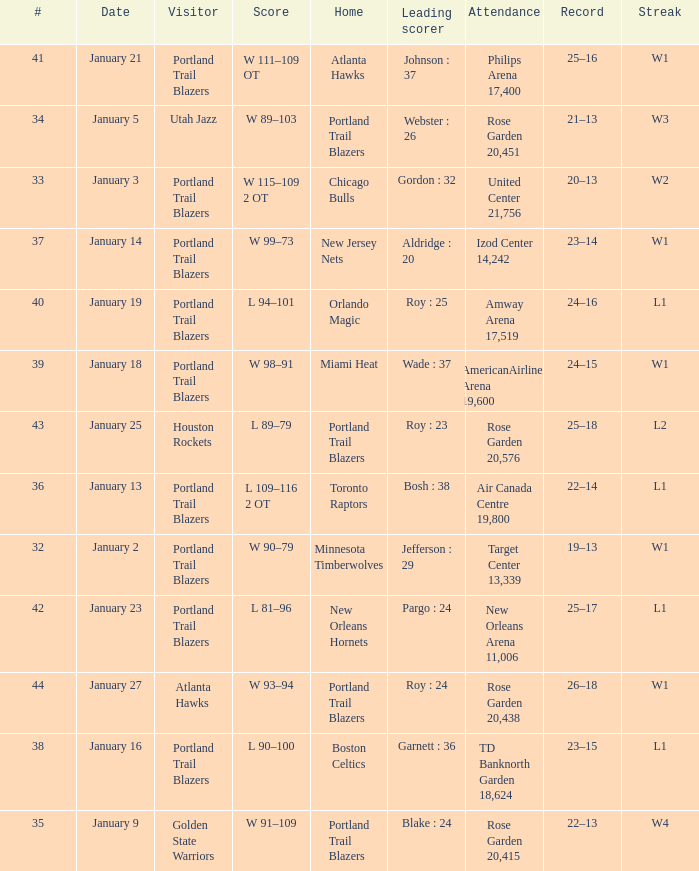Who are all the visitor with a record of 25–18 Houston Rockets. Could you parse the entire table as a dict? {'header': ['#', 'Date', 'Visitor', 'Score', 'Home', 'Leading scorer', 'Attendance', 'Record', 'Streak'], 'rows': [['41', 'January 21', 'Portland Trail Blazers', 'W 111–109 OT', 'Atlanta Hawks', 'Johnson : 37', 'Philips Arena 17,400', '25–16', 'W1'], ['34', 'January 5', 'Utah Jazz', 'W 89–103', 'Portland Trail Blazers', 'Webster : 26', 'Rose Garden 20,451', '21–13', 'W3'], ['33', 'January 3', 'Portland Trail Blazers', 'W 115–109 2 OT', 'Chicago Bulls', 'Gordon : 32', 'United Center 21,756', '20–13', 'W2'], ['37', 'January 14', 'Portland Trail Blazers', 'W 99–73', 'New Jersey Nets', 'Aldridge : 20', 'Izod Center 14,242', '23–14', 'W1'], ['40', 'January 19', 'Portland Trail Blazers', 'L 94–101', 'Orlando Magic', 'Roy : 25', 'Amway Arena 17,519', '24–16', 'L1'], ['39', 'January 18', 'Portland Trail Blazers', 'W 98–91', 'Miami Heat', 'Wade : 37', 'AmericanAirlines Arena 19,600', '24–15', 'W1'], ['43', 'January 25', 'Houston Rockets', 'L 89–79', 'Portland Trail Blazers', 'Roy : 23', 'Rose Garden 20,576', '25–18', 'L2'], ['36', 'January 13', 'Portland Trail Blazers', 'L 109–116 2 OT', 'Toronto Raptors', 'Bosh : 38', 'Air Canada Centre 19,800', '22–14', 'L1'], ['32', 'January 2', 'Portland Trail Blazers', 'W 90–79', 'Minnesota Timberwolves', 'Jefferson : 29', 'Target Center 13,339', '19–13', 'W1'], ['42', 'January 23', 'Portland Trail Blazers', 'L 81–96', 'New Orleans Hornets', 'Pargo : 24', 'New Orleans Arena 11,006', '25–17', 'L1'], ['44', 'January 27', 'Atlanta Hawks', 'W 93–94', 'Portland Trail Blazers', 'Roy : 24', 'Rose Garden 20,438', '26–18', 'W1'], ['38', 'January 16', 'Portland Trail Blazers', 'L 90–100', 'Boston Celtics', 'Garnett : 36', 'TD Banknorth Garden 18,624', '23–15', 'L1'], ['35', 'January 9', 'Golden State Warriors', 'W 91–109', 'Portland Trail Blazers', 'Blake : 24', 'Rose Garden 20,415', '22–13', 'W4']]} 